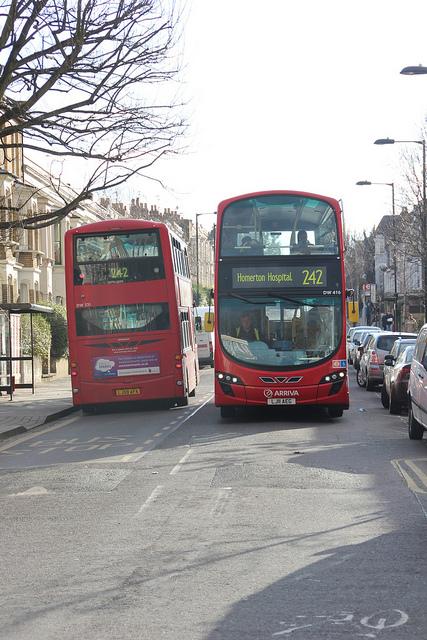Are both buses going the same direction?
Give a very brief answer. No. How tall is the bus?
Quick response, please. Double decker. What numbers are on the bus headers?
Keep it brief. 242. 